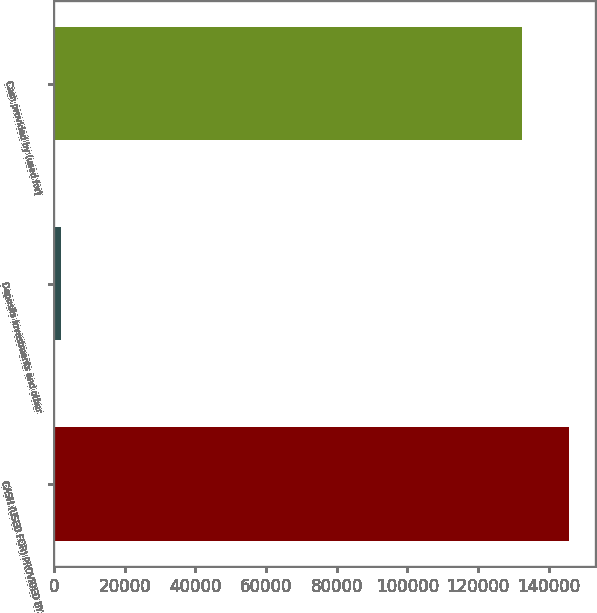Convert chart. <chart><loc_0><loc_0><loc_500><loc_500><bar_chart><fcel>CASH (USED FOR) PROVIDED BY<fcel>Deposits investments and other<fcel>Cash provided by (used for)<nl><fcel>145794<fcel>2000<fcel>132540<nl></chart> 